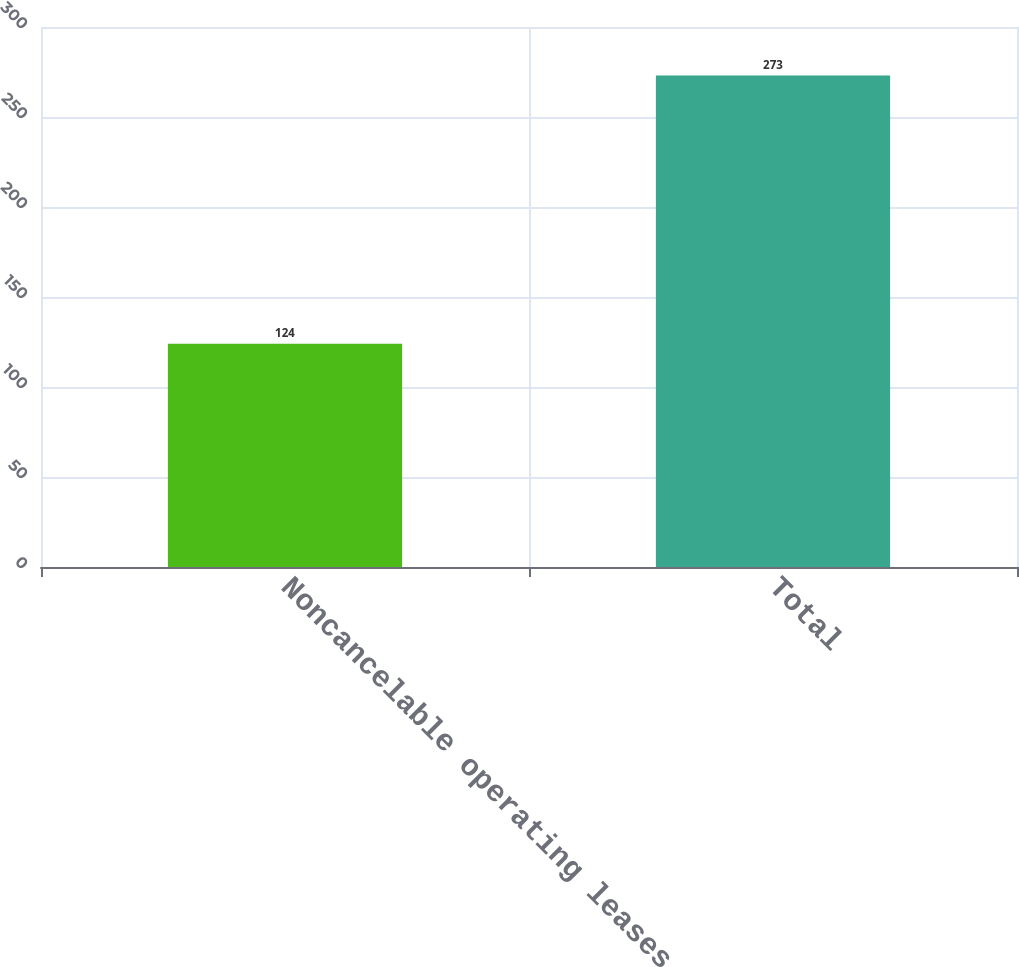<chart> <loc_0><loc_0><loc_500><loc_500><bar_chart><fcel>Noncancelable operating leases<fcel>Total<nl><fcel>124<fcel>273<nl></chart> 